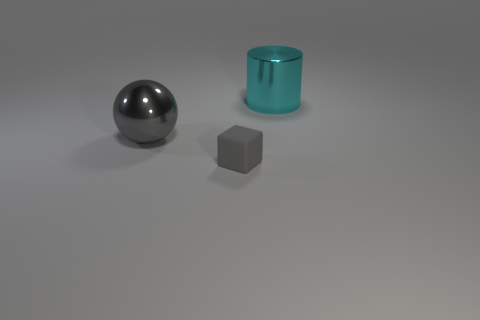Add 2 yellow shiny cylinders. How many yellow shiny cylinders exist? 2 Add 3 large gray shiny balls. How many objects exist? 6 Subtract 1 gray blocks. How many objects are left? 2 Subtract all purple cylinders. Subtract all big gray spheres. How many objects are left? 2 Add 1 gray matte cubes. How many gray matte cubes are left? 2 